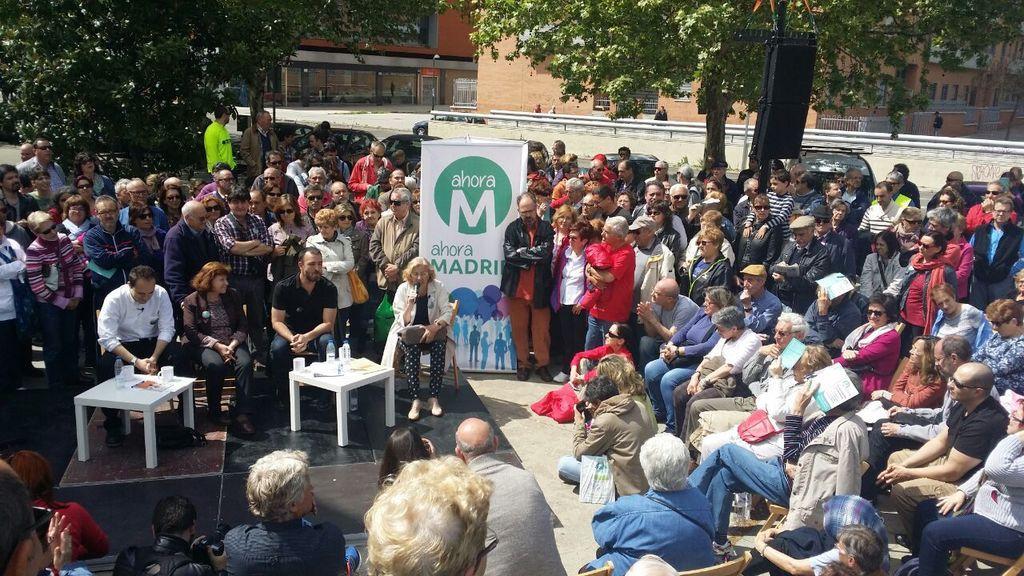Please provide a concise description of this image. There is a group of people. some people are standing and some people are sitting in a chair. There is a table. There is a glass on a table. In the center we have a person. She is holding a mic and she is talking. Everyone is listening to her. we can in the background there is a tree,building and name poster. 